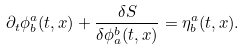<formula> <loc_0><loc_0><loc_500><loc_500>\partial _ { t } \phi ^ { a } _ { b } ( t , x ) + \frac { \delta S } { \delta \phi ^ { b } _ { a } ( t , x ) } = \eta ^ { a } _ { b } ( t , x ) .</formula> 